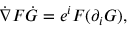Convert formula to latex. <formula><loc_0><loc_0><loc_500><loc_500>{ \dot { \nabla } } F { \dot { G } } = e ^ { i } F ( \partial _ { i } G ) ,</formula> 